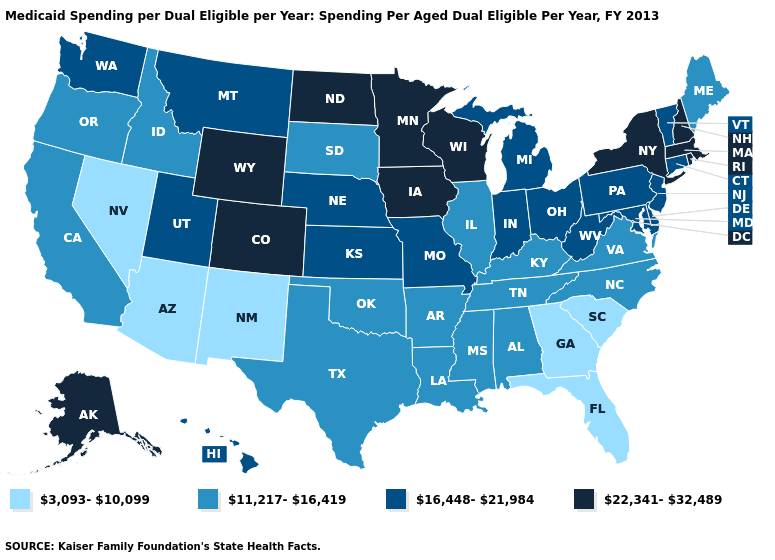Among the states that border Georgia , which have the highest value?
Quick response, please. Alabama, North Carolina, Tennessee. How many symbols are there in the legend?
Be succinct. 4. What is the value of Rhode Island?
Write a very short answer. 22,341-32,489. What is the value of Wisconsin?
Short answer required. 22,341-32,489. Does the map have missing data?
Be succinct. No. Which states have the lowest value in the West?
Be succinct. Arizona, Nevada, New Mexico. What is the value of Wisconsin?
Give a very brief answer. 22,341-32,489. Which states have the lowest value in the USA?
Concise answer only. Arizona, Florida, Georgia, Nevada, New Mexico, South Carolina. What is the highest value in the USA?
Write a very short answer. 22,341-32,489. What is the highest value in the USA?
Give a very brief answer. 22,341-32,489. Name the states that have a value in the range 16,448-21,984?
Be succinct. Connecticut, Delaware, Hawaii, Indiana, Kansas, Maryland, Michigan, Missouri, Montana, Nebraska, New Jersey, Ohio, Pennsylvania, Utah, Vermont, Washington, West Virginia. Does Kentucky have a higher value than Georgia?
Write a very short answer. Yes. Name the states that have a value in the range 3,093-10,099?
Short answer required. Arizona, Florida, Georgia, Nevada, New Mexico, South Carolina. How many symbols are there in the legend?
Short answer required. 4. What is the highest value in the West ?
Quick response, please. 22,341-32,489. 